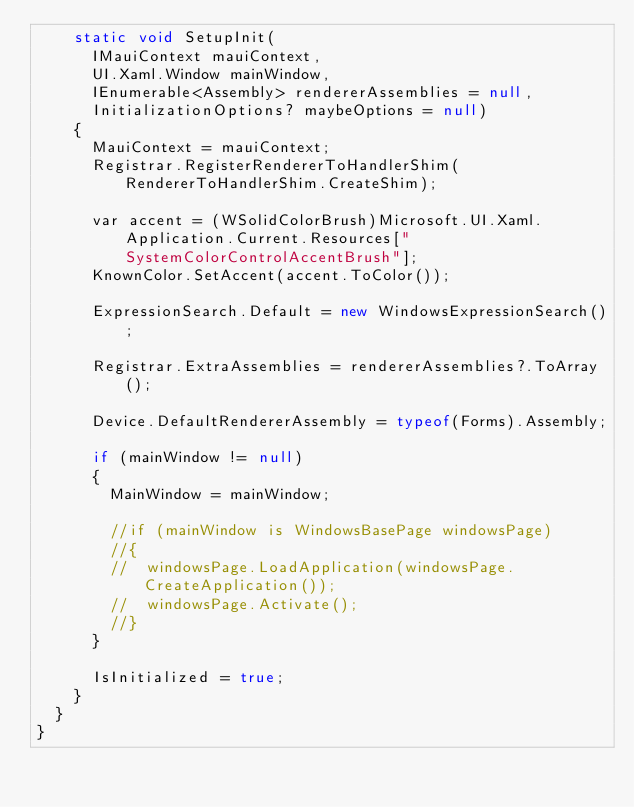Convert code to text. <code><loc_0><loc_0><loc_500><loc_500><_C#_>		static void SetupInit(
			IMauiContext mauiContext,
			UI.Xaml.Window mainWindow,
			IEnumerable<Assembly> rendererAssemblies = null,
			InitializationOptions? maybeOptions = null)
		{
			MauiContext = mauiContext;
			Registrar.RegisterRendererToHandlerShim(RendererToHandlerShim.CreateShim);

			var accent = (WSolidColorBrush)Microsoft.UI.Xaml.Application.Current.Resources["SystemColorControlAccentBrush"];
			KnownColor.SetAccent(accent.ToColor());

			ExpressionSearch.Default = new WindowsExpressionSearch();

			Registrar.ExtraAssemblies = rendererAssemblies?.ToArray();

			Device.DefaultRendererAssembly = typeof(Forms).Assembly;

			if (mainWindow != null)
			{
				MainWindow = mainWindow;

				//if (mainWindow is WindowsBasePage windowsPage)
				//{
				//	windowsPage.LoadApplication(windowsPage.CreateApplication());
				//	windowsPage.Activate();
				//}
			}

			IsInitialized = true;
		}
	}
}</code> 